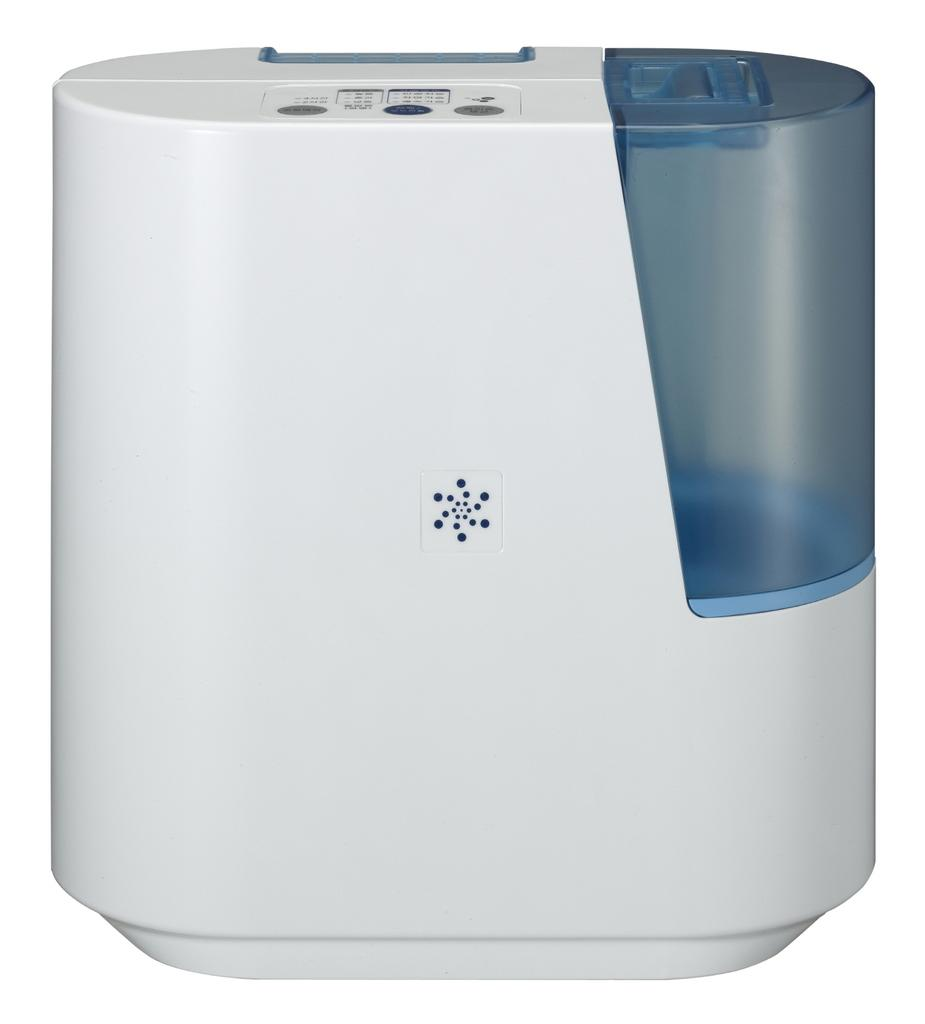What object is the main focus of the image? There is a water filter in the image. What colors are used for the water filter? The water filter is white and blue in color. What color is the background of the image? The background of the image is white. What type of reaction can be seen between the books and the truck in the image? There are no books or truck present in the image; it only features a water filter. 